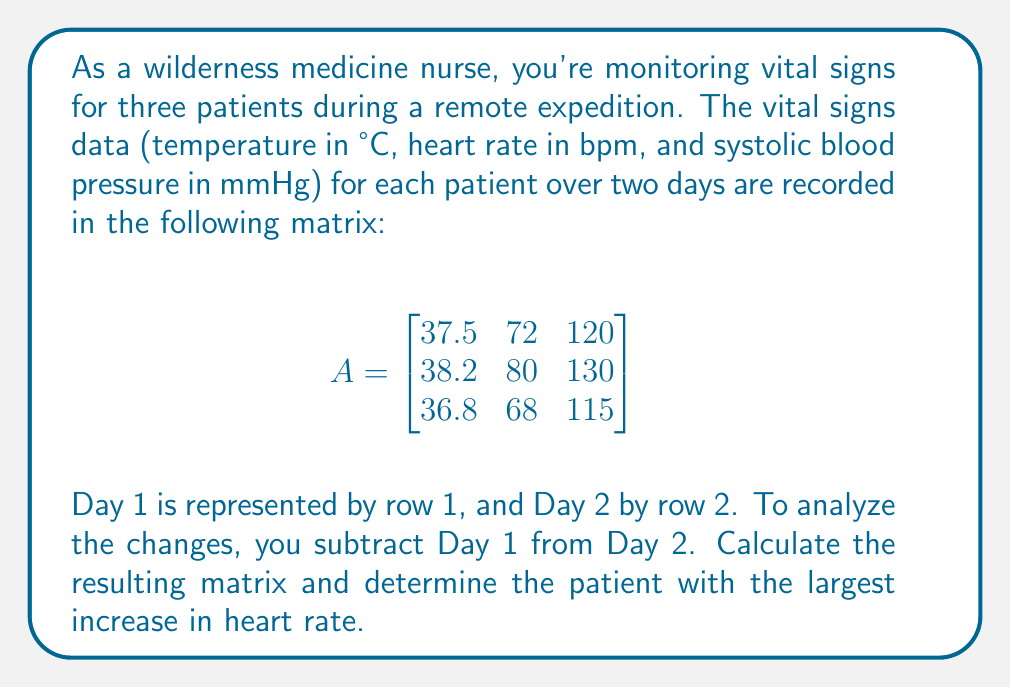Give your solution to this math problem. Let's approach this step-by-step:

1) First, we need to create a matrix representing the changes from Day 1 to Day 2. We'll call this matrix B.

2) To get B, we subtract row 1 of matrix A from row 2:

   $$B = \begin{bmatrix}
   38.2 - 37.5 & 80 - 72 & 130 - 120 \\
   36.8 - 37.5 & 68 - 72 & 115 - 120
   \end{bmatrix}$$

3) Calculating the differences:

   $$B = \begin{bmatrix}
   0.7 & 8 & 10 \\
   -0.7 & -4 & -5
   \end{bmatrix}$$

4) Now, we need to identify the largest increase in heart rate. Heart rate is represented by the middle column.

5) In the middle column, we see:
   - Patient 1: 8 bpm increase
   - Patient 2: 4 bpm decrease

6) The largest increase is 8 bpm, corresponding to Patient 1.
Answer: Patient 1 